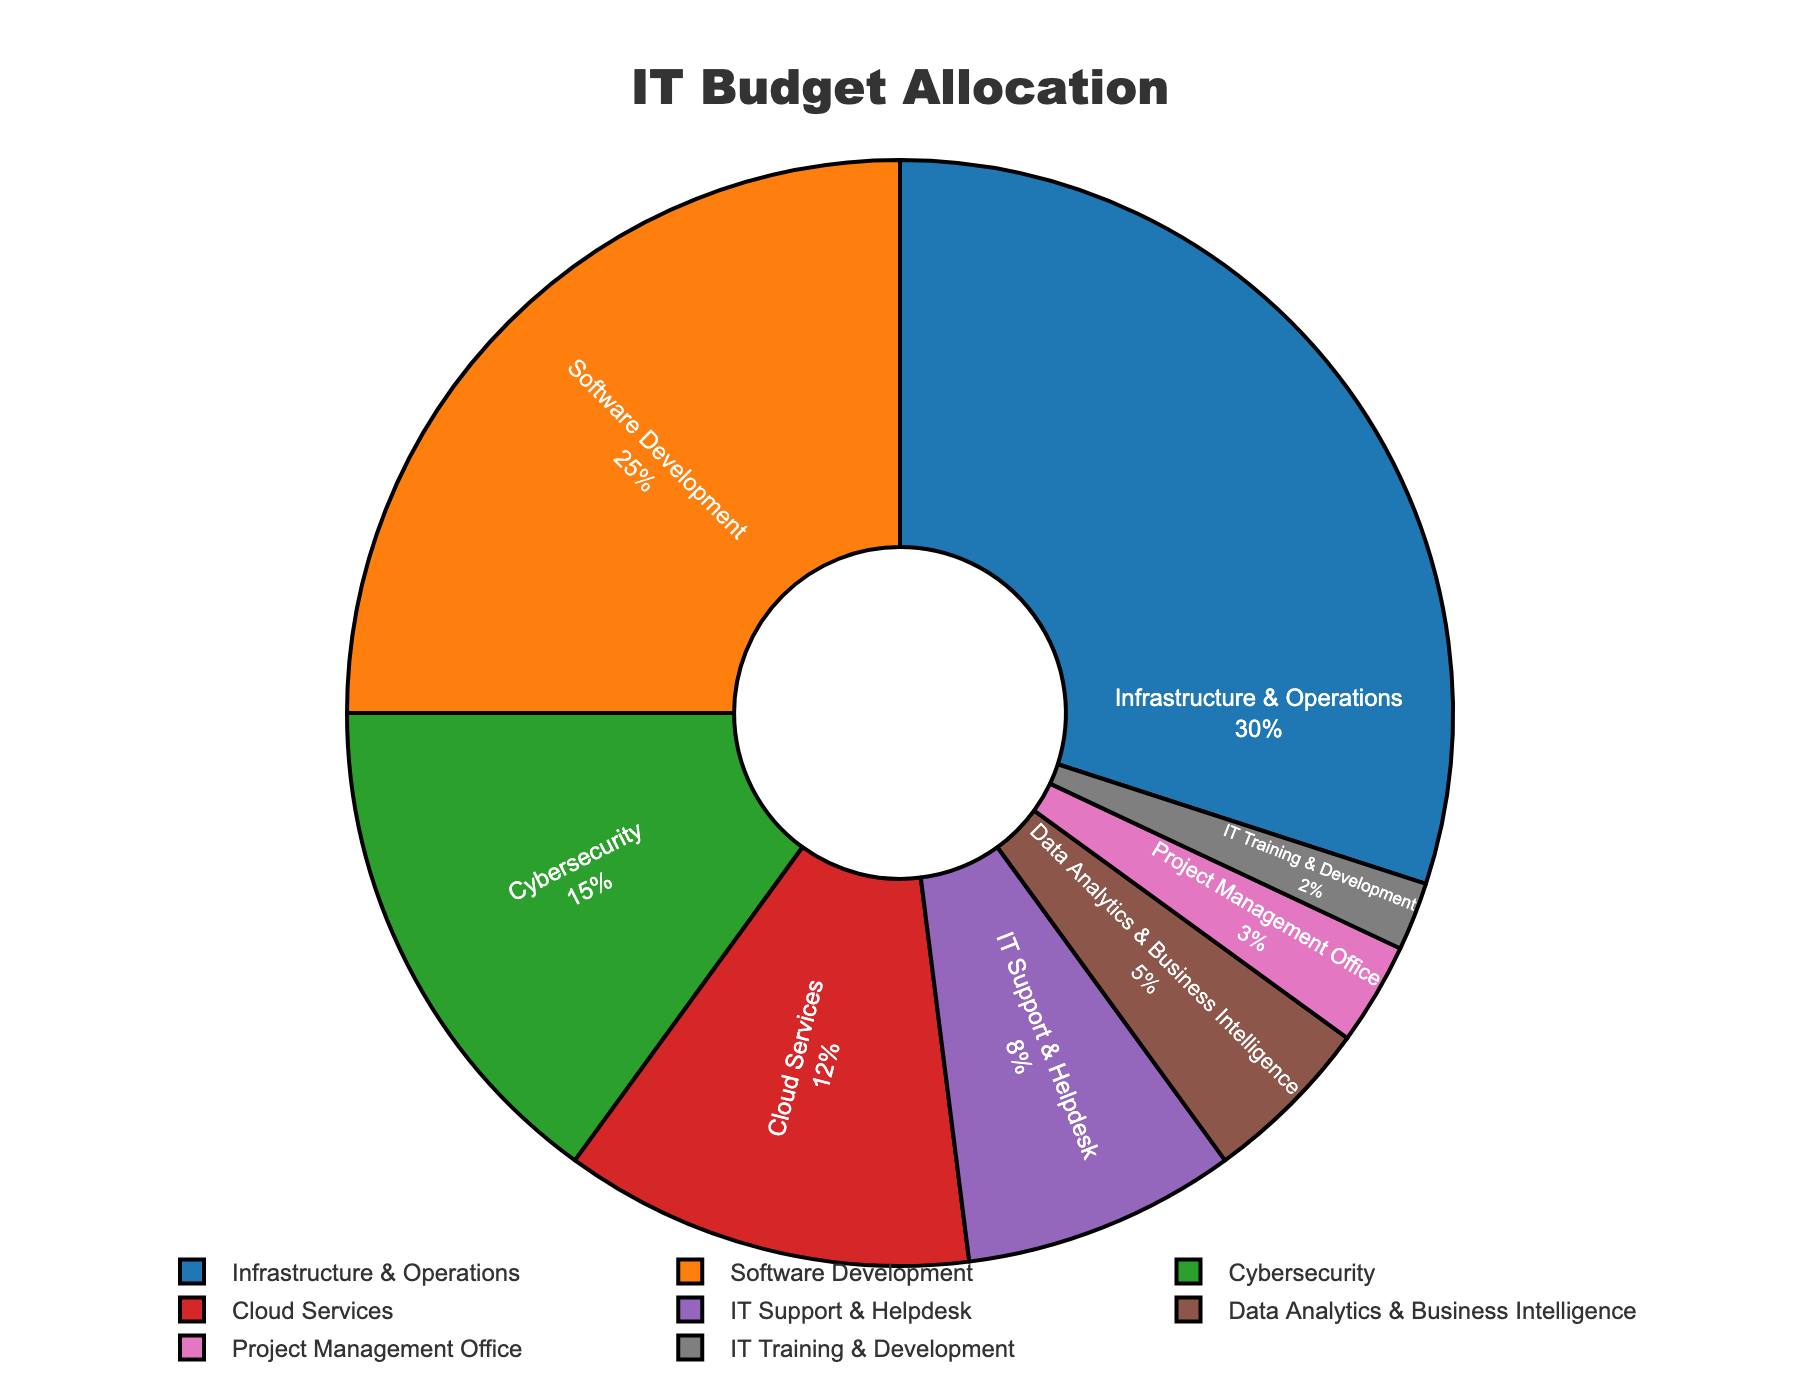Which department receives the highest percentage of the IT budget? The department receiving the highest percentage of the IT budget is "Infrastructure & Operations" at 30%.
Answer: Infrastructure & Operations Which two departments together receive the same percentage as the "Software Development" department alone? The departments "IT Support & Helpdesk" and "Data Analytics & Business Intelligence" together receive 8% + 5% = 13%, which matches the 25% allocated to "Software Development".
Answer: IT Support & Helpdesk and Data Analytics & Business Intelligence How much more budget percentage is allocated to "Cloud Services" compared to "IT Training & Development"? "Cloud Services" is allocated 12%, while "IT Training & Development" is allocated 2%. The difference is 12% - 2% = 10%.
Answer: 10% What is the combined budget allocation for "Cybersecurity" and "Project Management Office"? "Cybersecurity" has 15% and "Project Management Office" has 3%. Combined, they have 15% + 3% = 18% of the budget.
Answer: 18% Which department has the smallest budget allocation, and what is its percentage? The department with the smallest allocation is "IT Training & Development" at 2%.
Answer: IT Training & Development Is the budget allocation for "Infrastructure & Operations" more than twice that of "Cloud Services"? "Infrastructure & Operations" has 30%, and twice the "Cloud Services" allocation is 2 * 12% = 24%. Since 30% is more than 24%, the allocation is more than twice.
Answer: Yes Compare the total budget percentage of "IT Support & Helpdesk" and "Data Analytics & Business Intelligence" with "Cloud Services". Which is greater? "IT Support & Helpdesk" and "Data Analytics & Business Intelligence" together have 8% + 5% = 13%. "Cloud Services" has 12%. Since 13% is greater than 12%, the former is greater.
Answer: IT Support & Helpdesk and Data Analytics & Business Intelligence How does the budget allocation of "Software Development" compare with the sum of "Cybersecurity" and "IT Support & Helpdesk"? "Software Development" has 25%, while "Cybersecurity" and "IT Support & Helpdesk" together have 15% + 8% = 23%. "Software Development" has 2% more.
Answer: Software Development has 2% more 